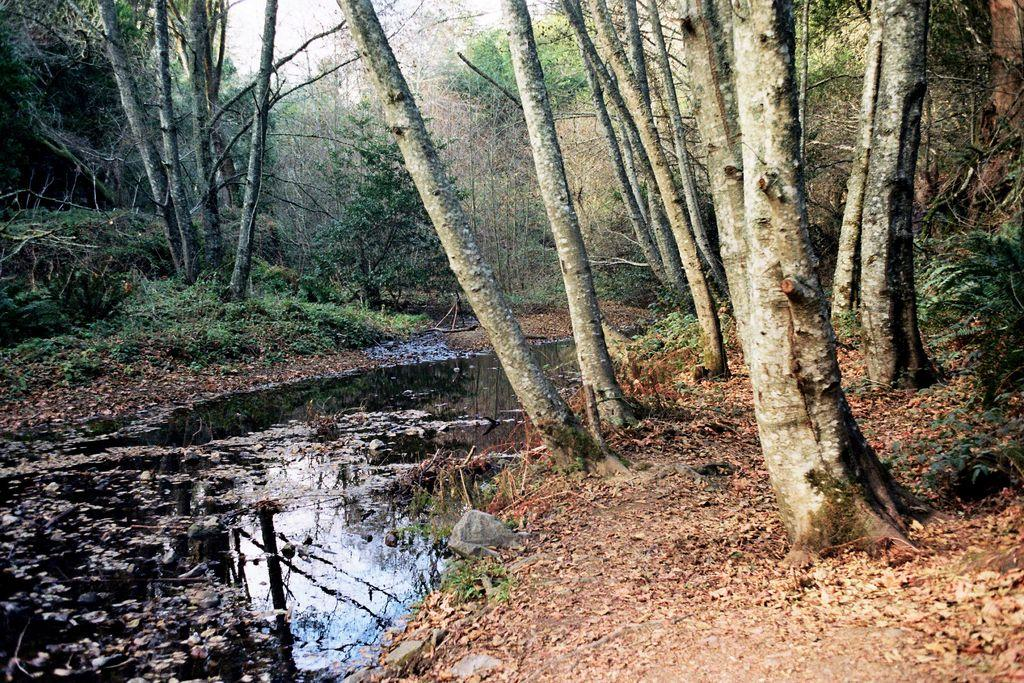What is the primary element visible in the image? There is water in the image. What type of vegetation can be seen in the image? There are plants in the image. What can be seen in the background of the image? There are trees and the sky visible in the background of the image. What type of coil is used to support the plants in the image? There is no coil present in the image; the plants are not supported by any visible coil. 